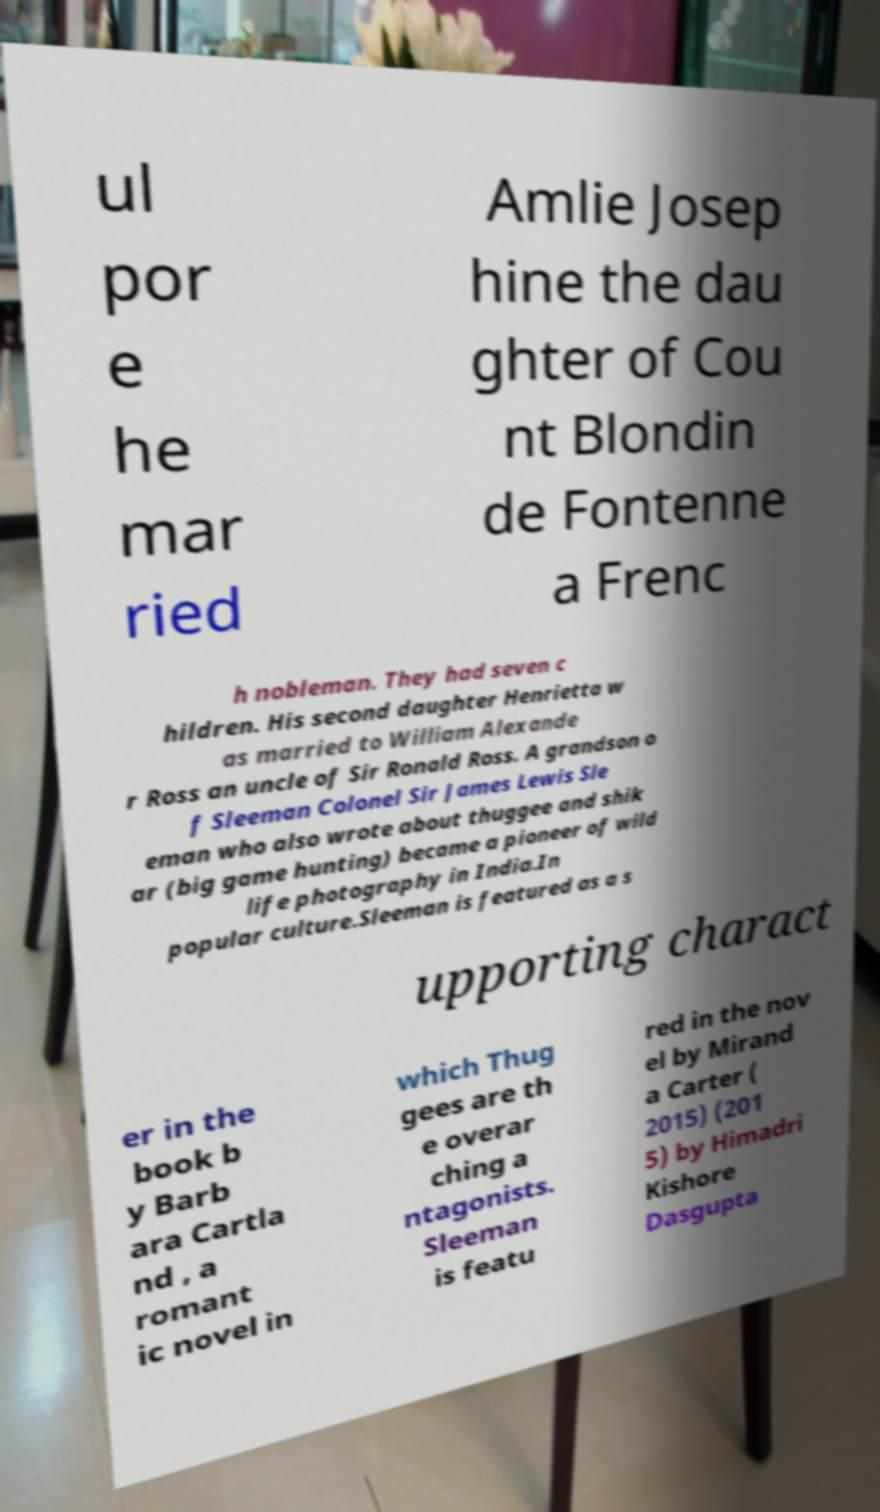I need the written content from this picture converted into text. Can you do that? ul por e he mar ried Amlie Josep hine the dau ghter of Cou nt Blondin de Fontenne a Frenc h nobleman. They had seven c hildren. His second daughter Henrietta w as married to William Alexande r Ross an uncle of Sir Ronald Ross. A grandson o f Sleeman Colonel Sir James Lewis Sle eman who also wrote about thuggee and shik ar (big game hunting) became a pioneer of wild life photography in India.In popular culture.Sleeman is featured as a s upporting charact er in the book b y Barb ara Cartla nd , a romant ic novel in which Thug gees are th e overar ching a ntagonists. Sleeman is featu red in the nov el by Mirand a Carter ( 2015) (201 5) by Himadri Kishore Dasgupta 